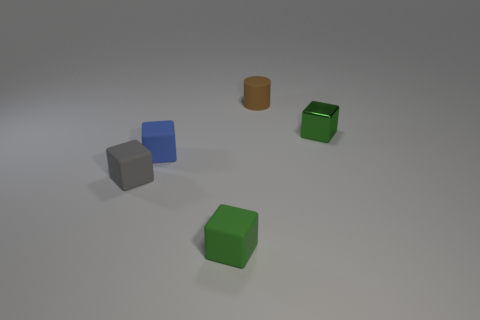What number of small green objects are there? 2 